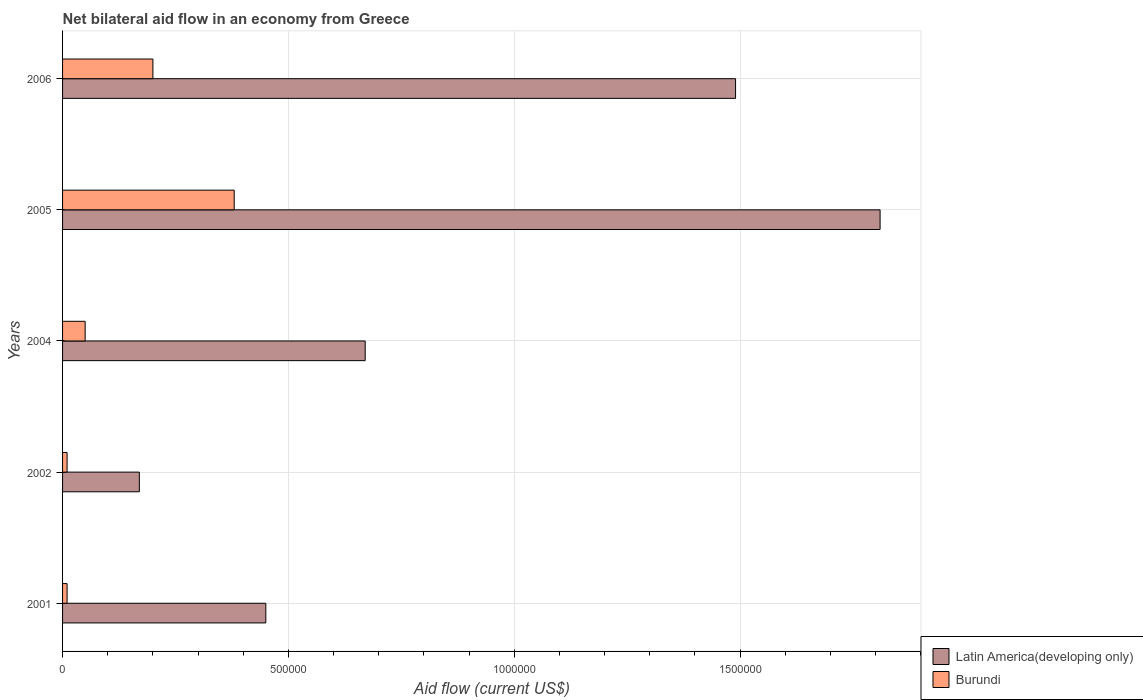How many groups of bars are there?
Keep it short and to the point. 5. Are the number of bars per tick equal to the number of legend labels?
Make the answer very short. Yes. What is the label of the 2nd group of bars from the top?
Your answer should be very brief. 2005. What is the net bilateral aid flow in Latin America(developing only) in 2006?
Give a very brief answer. 1.49e+06. Across all years, what is the minimum net bilateral aid flow in Latin America(developing only)?
Your response must be concise. 1.70e+05. What is the total net bilateral aid flow in Burundi in the graph?
Provide a succinct answer. 6.50e+05. What is the difference between the net bilateral aid flow in Latin America(developing only) in 2001 and that in 2006?
Keep it short and to the point. -1.04e+06. What is the difference between the net bilateral aid flow in Burundi in 2006 and the net bilateral aid flow in Latin America(developing only) in 2002?
Keep it short and to the point. 3.00e+04. In the year 2001, what is the difference between the net bilateral aid flow in Burundi and net bilateral aid flow in Latin America(developing only)?
Keep it short and to the point. -4.40e+05. In how many years, is the net bilateral aid flow in Burundi greater than 800000 US$?
Make the answer very short. 0. What is the ratio of the net bilateral aid flow in Burundi in 2002 to that in 2005?
Offer a terse response. 0.03. Is the net bilateral aid flow in Latin America(developing only) in 2001 less than that in 2002?
Your response must be concise. No. Is the difference between the net bilateral aid flow in Burundi in 2005 and 2006 greater than the difference between the net bilateral aid flow in Latin America(developing only) in 2005 and 2006?
Your answer should be very brief. No. What is the difference between the highest and the lowest net bilateral aid flow in Burundi?
Provide a short and direct response. 3.70e+05. What does the 1st bar from the top in 2002 represents?
Make the answer very short. Burundi. What does the 1st bar from the bottom in 2004 represents?
Your answer should be very brief. Latin America(developing only). Does the graph contain any zero values?
Give a very brief answer. No. Does the graph contain grids?
Make the answer very short. Yes. Where does the legend appear in the graph?
Ensure brevity in your answer.  Bottom right. How are the legend labels stacked?
Keep it short and to the point. Vertical. What is the title of the graph?
Offer a terse response. Net bilateral aid flow in an economy from Greece. What is the label or title of the X-axis?
Keep it short and to the point. Aid flow (current US$). What is the label or title of the Y-axis?
Offer a very short reply. Years. What is the Aid flow (current US$) of Latin America(developing only) in 2004?
Your answer should be compact. 6.70e+05. What is the Aid flow (current US$) in Burundi in 2004?
Offer a very short reply. 5.00e+04. What is the Aid flow (current US$) in Latin America(developing only) in 2005?
Your response must be concise. 1.81e+06. What is the Aid flow (current US$) in Latin America(developing only) in 2006?
Offer a very short reply. 1.49e+06. Across all years, what is the maximum Aid flow (current US$) of Latin America(developing only)?
Offer a terse response. 1.81e+06. Across all years, what is the minimum Aid flow (current US$) of Latin America(developing only)?
Offer a terse response. 1.70e+05. What is the total Aid flow (current US$) of Latin America(developing only) in the graph?
Your answer should be compact. 4.59e+06. What is the total Aid flow (current US$) in Burundi in the graph?
Ensure brevity in your answer.  6.50e+05. What is the difference between the Aid flow (current US$) in Latin America(developing only) in 2001 and that in 2002?
Ensure brevity in your answer.  2.80e+05. What is the difference between the Aid flow (current US$) of Latin America(developing only) in 2001 and that in 2004?
Offer a very short reply. -2.20e+05. What is the difference between the Aid flow (current US$) of Burundi in 2001 and that in 2004?
Your answer should be very brief. -4.00e+04. What is the difference between the Aid flow (current US$) of Latin America(developing only) in 2001 and that in 2005?
Provide a short and direct response. -1.36e+06. What is the difference between the Aid flow (current US$) in Burundi in 2001 and that in 2005?
Give a very brief answer. -3.70e+05. What is the difference between the Aid flow (current US$) of Latin America(developing only) in 2001 and that in 2006?
Keep it short and to the point. -1.04e+06. What is the difference between the Aid flow (current US$) in Latin America(developing only) in 2002 and that in 2004?
Keep it short and to the point. -5.00e+05. What is the difference between the Aid flow (current US$) in Burundi in 2002 and that in 2004?
Provide a succinct answer. -4.00e+04. What is the difference between the Aid flow (current US$) of Latin America(developing only) in 2002 and that in 2005?
Keep it short and to the point. -1.64e+06. What is the difference between the Aid flow (current US$) of Burundi in 2002 and that in 2005?
Your answer should be compact. -3.70e+05. What is the difference between the Aid flow (current US$) of Latin America(developing only) in 2002 and that in 2006?
Keep it short and to the point. -1.32e+06. What is the difference between the Aid flow (current US$) of Latin America(developing only) in 2004 and that in 2005?
Provide a succinct answer. -1.14e+06. What is the difference between the Aid flow (current US$) of Burundi in 2004 and that in 2005?
Make the answer very short. -3.30e+05. What is the difference between the Aid flow (current US$) in Latin America(developing only) in 2004 and that in 2006?
Your answer should be very brief. -8.20e+05. What is the difference between the Aid flow (current US$) of Latin America(developing only) in 2005 and that in 2006?
Provide a succinct answer. 3.20e+05. What is the difference between the Aid flow (current US$) of Burundi in 2005 and that in 2006?
Your answer should be very brief. 1.80e+05. What is the difference between the Aid flow (current US$) in Latin America(developing only) in 2001 and the Aid flow (current US$) in Burundi in 2002?
Make the answer very short. 4.40e+05. What is the difference between the Aid flow (current US$) of Latin America(developing only) in 2001 and the Aid flow (current US$) of Burundi in 2004?
Provide a short and direct response. 4.00e+05. What is the difference between the Aid flow (current US$) of Latin America(developing only) in 2002 and the Aid flow (current US$) of Burundi in 2004?
Your answer should be compact. 1.20e+05. What is the difference between the Aid flow (current US$) of Latin America(developing only) in 2002 and the Aid flow (current US$) of Burundi in 2006?
Your answer should be very brief. -3.00e+04. What is the difference between the Aid flow (current US$) of Latin America(developing only) in 2005 and the Aid flow (current US$) of Burundi in 2006?
Offer a very short reply. 1.61e+06. What is the average Aid flow (current US$) in Latin America(developing only) per year?
Your response must be concise. 9.18e+05. What is the average Aid flow (current US$) of Burundi per year?
Ensure brevity in your answer.  1.30e+05. In the year 2001, what is the difference between the Aid flow (current US$) of Latin America(developing only) and Aid flow (current US$) of Burundi?
Ensure brevity in your answer.  4.40e+05. In the year 2004, what is the difference between the Aid flow (current US$) of Latin America(developing only) and Aid flow (current US$) of Burundi?
Make the answer very short. 6.20e+05. In the year 2005, what is the difference between the Aid flow (current US$) of Latin America(developing only) and Aid flow (current US$) of Burundi?
Offer a very short reply. 1.43e+06. In the year 2006, what is the difference between the Aid flow (current US$) in Latin America(developing only) and Aid flow (current US$) in Burundi?
Offer a very short reply. 1.29e+06. What is the ratio of the Aid flow (current US$) of Latin America(developing only) in 2001 to that in 2002?
Keep it short and to the point. 2.65. What is the ratio of the Aid flow (current US$) in Latin America(developing only) in 2001 to that in 2004?
Your response must be concise. 0.67. What is the ratio of the Aid flow (current US$) in Latin America(developing only) in 2001 to that in 2005?
Keep it short and to the point. 0.25. What is the ratio of the Aid flow (current US$) of Burundi in 2001 to that in 2005?
Ensure brevity in your answer.  0.03. What is the ratio of the Aid flow (current US$) of Latin America(developing only) in 2001 to that in 2006?
Give a very brief answer. 0.3. What is the ratio of the Aid flow (current US$) of Latin America(developing only) in 2002 to that in 2004?
Provide a succinct answer. 0.25. What is the ratio of the Aid flow (current US$) in Burundi in 2002 to that in 2004?
Ensure brevity in your answer.  0.2. What is the ratio of the Aid flow (current US$) of Latin America(developing only) in 2002 to that in 2005?
Your answer should be very brief. 0.09. What is the ratio of the Aid flow (current US$) of Burundi in 2002 to that in 2005?
Your answer should be very brief. 0.03. What is the ratio of the Aid flow (current US$) of Latin America(developing only) in 2002 to that in 2006?
Give a very brief answer. 0.11. What is the ratio of the Aid flow (current US$) in Latin America(developing only) in 2004 to that in 2005?
Your answer should be very brief. 0.37. What is the ratio of the Aid flow (current US$) of Burundi in 2004 to that in 2005?
Offer a very short reply. 0.13. What is the ratio of the Aid flow (current US$) in Latin America(developing only) in 2004 to that in 2006?
Provide a short and direct response. 0.45. What is the ratio of the Aid flow (current US$) of Burundi in 2004 to that in 2006?
Provide a succinct answer. 0.25. What is the ratio of the Aid flow (current US$) of Latin America(developing only) in 2005 to that in 2006?
Provide a succinct answer. 1.21. What is the difference between the highest and the second highest Aid flow (current US$) in Latin America(developing only)?
Provide a short and direct response. 3.20e+05. What is the difference between the highest and the lowest Aid flow (current US$) of Latin America(developing only)?
Your response must be concise. 1.64e+06. 